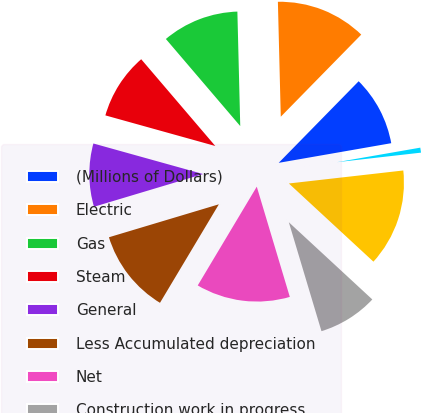Convert chart to OTSL. <chart><loc_0><loc_0><loc_500><loc_500><pie_chart><fcel>(Millions of Dollars)<fcel>Electric<fcel>Gas<fcel>Steam<fcel>General<fcel>Less Accumulated depreciation<fcel>Net<fcel>Construction work in progress<fcel>Net Utility Plant<fcel>Non-utility property less<nl><fcel>9.91%<fcel>12.74%<fcel>10.85%<fcel>9.43%<fcel>8.96%<fcel>11.79%<fcel>13.21%<fcel>8.49%<fcel>13.68%<fcel>0.95%<nl></chart> 